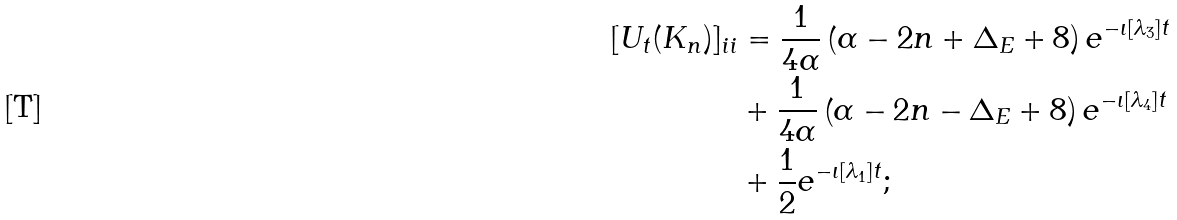<formula> <loc_0><loc_0><loc_500><loc_500>[ U _ { t } ( K _ { n } ) ] _ { i i } & = \frac { 1 } { 4 \alpha } \left ( \alpha - 2 n + \Delta _ { E } + 8 \right ) e ^ { - \iota \left [ \lambda _ { 3 } \right ] t } \\ & + \frac { 1 } { 4 \alpha } \left ( \alpha - 2 n - \Delta _ { E } + 8 \right ) e ^ { - \iota \left [ \lambda _ { 4 } \right ] t } \\ & + \frac { 1 } { 2 } e ^ { - \iota \left [ \lambda _ { 1 } \right ] t } ;</formula> 